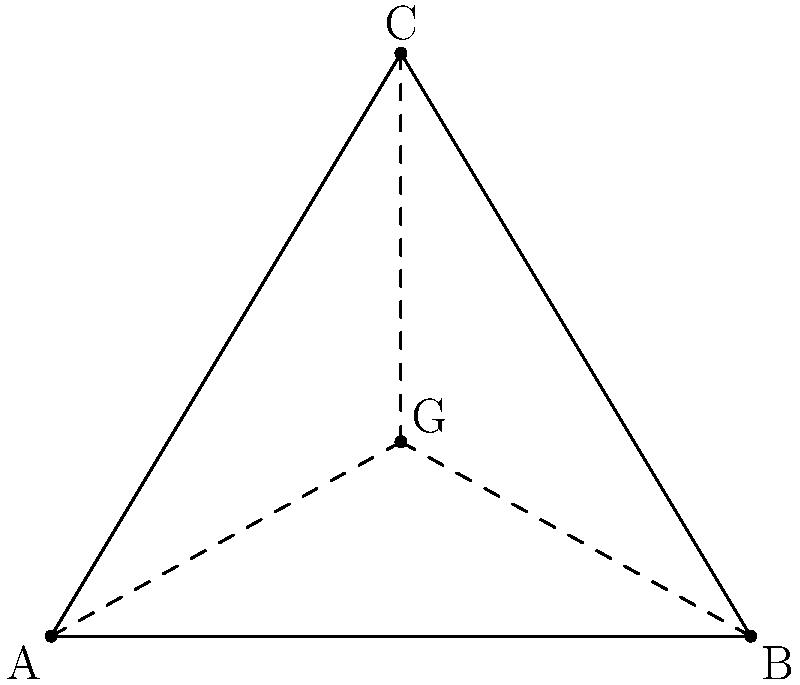In a debate about geometric principles, you're presented with a triangle ABC where A(0,0), B(6,0), and C(3,5) are the coordinates of its vertices. To strengthen your argument, you need to find the exact coordinates of the centroid (G) of this triangle. What are the coordinates of the centroid? To find the coordinates of the centroid of a triangle, we can follow these steps:

1) The centroid of a triangle is located at the intersection of its medians. It divides each median in a 2:1 ratio, with the longer segment closer to the vertex.

2) The coordinates of the centroid can be calculated using the formula:

   $G_x = \frac{x_A + x_B + x_C}{3}$ and $G_y = \frac{y_A + y_B + y_C}{3}$

   Where $(x_A, y_A)$, $(x_B, y_B)$, and $(x_C, y_C)$ are the coordinates of the triangle's vertices.

3) Given:
   A(0,0), B(6,0), C(3,5)

4) Calculating $G_x$:
   $G_x = \frac{0 + 6 + 3}{3} = \frac{9}{3} = 3$

5) Calculating $G_y$:
   $G_y = \frac{0 + 0 + 5}{3} = \frac{5}{3}$

6) Therefore, the coordinates of the centroid G are (3, $\frac{5}{3}$).
Answer: (3, $\frac{5}{3}$) 